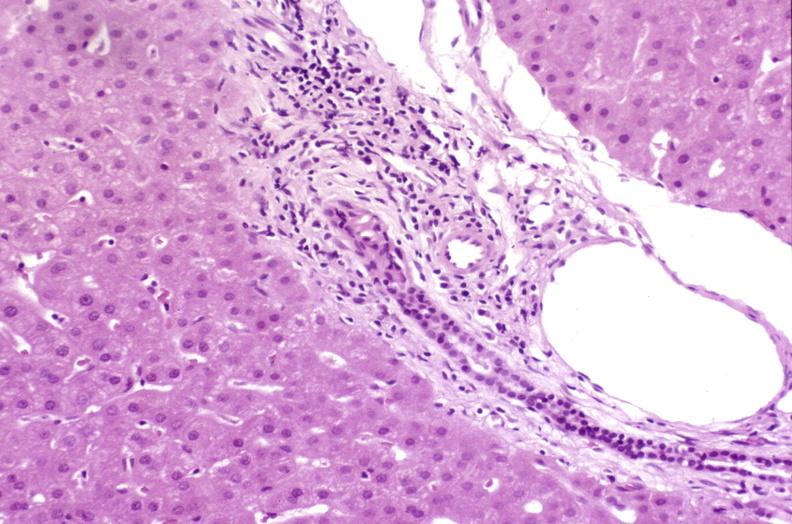s liver present?
Answer the question using a single word or phrase. Yes 